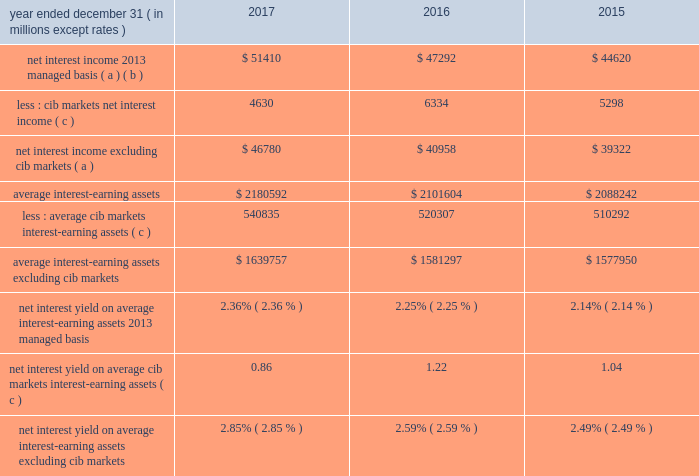Jpmorgan chase & co./2017 annual report 53 net interest income excluding cib 2019s markets businesses in addition to reviewing net interest income on a managed basis , management also reviews net interest income excluding net interest income arising from cib 2019s markets businesses to assess the performance of the firm 2019s lending , investing ( including asset-liability management ) and deposit-raising activities .
This net interest income is referred to as non-markets related net interest income .
Cib 2019s markets businesses are fixed income markets and equity markets .
Management believes that disclosure of non-markets related net interest income provides investors and analysts with another measure by which to analyze the non-markets-related business trends of the firm and provides a comparable measure to other financial institutions that are primarily focused on lending , investing and deposit-raising activities .
The data presented below are non-gaap financial measures due to the exclusion of markets related net interest income arising from cib .
Year ended december 31 , ( in millions , except rates ) 2017 2016 2015 net interest income 2013 managed basis ( a ) ( b ) $ 51410 $ 47292 $ 44620 less : cib markets net interest income ( c ) 4630 6334 5298 net interest income excluding cib markets ( a ) $ 46780 $ 40958 $ 39322 average interest-earning assets $ 2180592 $ 2101604 $ 2088242 less : average cib markets interest-earning assets ( c ) 540835 520307 510292 average interest-earning assets excluding cib markets $ 1639757 $ 1581297 $ 1577950 net interest yield on average interest-earning assets 2013 managed basis 2.36% ( 2.36 % ) 2.25% ( 2.25 % ) 2.14% ( 2.14 % ) net interest yield on average cib markets interest-earning assets ( c ) 0.86 1.22 1.04 net interest yield on average interest-earning assets excluding cib markets 2.85% ( 2.85 % ) 2.59% ( 2.59 % ) 2.49% ( 2.49 % ) ( a ) interest includes the effect of related hedges .
Taxable-equivalent amounts are used where applicable .
( b ) for a reconciliation of net interest income on a reported and managed basis , see reconciliation from the firm 2019s reported u.s .
Gaap results to managed basis on page 52 .
( c ) the amounts in this table differ from the prior-period presentation to align with cib 2019s markets businesses .
For further information on cib 2019s markets businesses , see page 65 .
Calculation of certain u.s .
Gaap and non-gaap financial measures certain u.s .
Gaap and non-gaap financial measures are calculated as follows : book value per share ( 201cbvps 201d ) common stockholders 2019 equity at period-end / common shares at period-end overhead ratio total noninterest expense / total net revenue return on assets ( 201croa 201d ) reported net income / total average assets return on common equity ( 201croe 201d ) net income* / average common stockholders 2019 equity return on tangible common equity ( 201crotce 201d ) net income* / average tangible common equity tangible book value per share ( 201ctbvps 201d ) tangible common equity at period-end / common shares at period-end * represents net income applicable to common equity .
Jpmorgan chase & co./2017 annual report 53 net interest income excluding cib 2019s markets businesses in addition to reviewing net interest income on a managed basis , management also reviews net interest income excluding net interest income arising from cib 2019s markets businesses to assess the performance of the firm 2019s lending , investing ( including asset-liability management ) and deposit-raising activities .
This net interest income is referred to as non-markets related net interest income .
Cib 2019s markets businesses are fixed income markets and equity markets .
Management believes that disclosure of non-markets related net interest income provides investors and analysts with another measure by which to analyze the non-markets-related business trends of the firm and provides a comparable measure to other financial institutions that are primarily focused on lending , investing and deposit-raising activities .
The data presented below are non-gaap financial measures due to the exclusion of markets related net interest income arising from cib .
Year ended december 31 , ( in millions , except rates ) 2017 2016 2015 net interest income 2013 managed basis ( a ) ( b ) $ 51410 $ 47292 $ 44620 less : cib markets net interest income ( c ) 4630 6334 5298 net interest income excluding cib markets ( a ) $ 46780 $ 40958 $ 39322 average interest-earning assets $ 2180592 $ 2101604 $ 2088242 less : average cib markets interest-earning assets ( c ) 540835 520307 510292 average interest-earning assets excluding cib markets $ 1639757 $ 1581297 $ 1577950 net interest yield on average interest-earning assets 2013 managed basis 2.36% ( 2.36 % ) 2.25% ( 2.25 % ) 2.14% ( 2.14 % ) net interest yield on average cib markets interest-earning assets ( c ) 0.86 1.22 1.04 net interest yield on average interest-earning assets excluding cib markets 2.85% ( 2.85 % ) 2.59% ( 2.59 % ) 2.49% ( 2.49 % ) ( a ) interest includes the effect of related hedges .
Taxable-equivalent amounts are used where applicable .
( b ) for a reconciliation of net interest income on a reported and managed basis , see reconciliation from the firm 2019s reported u.s .
Gaap results to managed basis on page 52 .
( c ) the amounts in this table differ from the prior-period presentation to align with cib 2019s markets businesses .
For further information on cib 2019s markets businesses , see page 65 .
Calculation of certain u.s .
Gaap and non-gaap financial measures certain u.s .
Gaap and non-gaap financial measures are calculated as follows : book value per share ( 201cbvps 201d ) common stockholders 2019 equity at period-end / common shares at period-end overhead ratio total noninterest expense / total net revenue return on assets ( 201croa 201d ) reported net income / total average assets return on common equity ( 201croe 201d ) net income* / average common stockholders 2019 equity return on tangible common equity ( 201crotce 201d ) net income* / average tangible common equity tangible book value per share ( 201ctbvps 201d ) tangible common equity at period-end / common shares at period-end * represents net income applicable to common equity .
For 2017 what was net interest income on average managed interest-earning assets in us$ m? 
Computations: (2.36% * 2180592)
Answer: 51461.9712. 